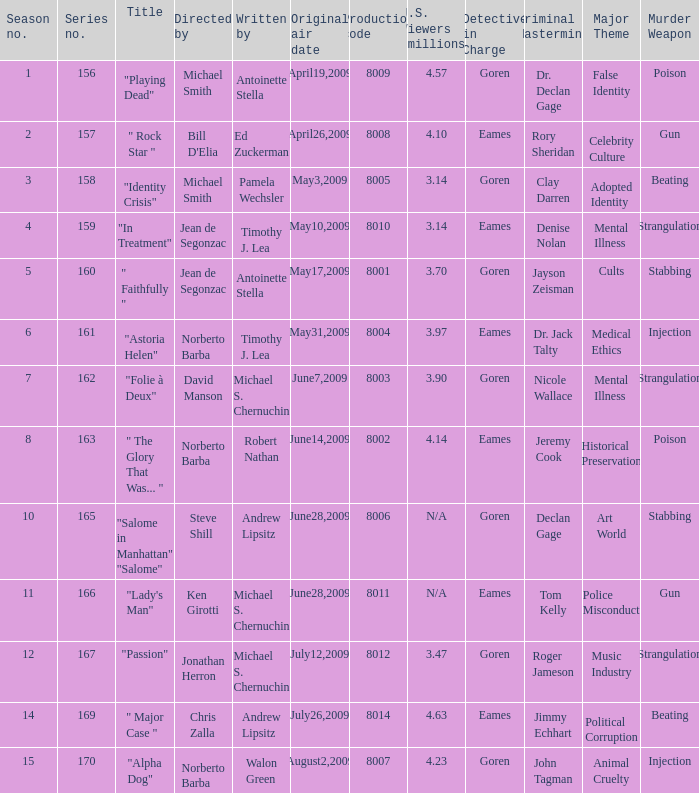Which is the biggest production code? 8014.0. 